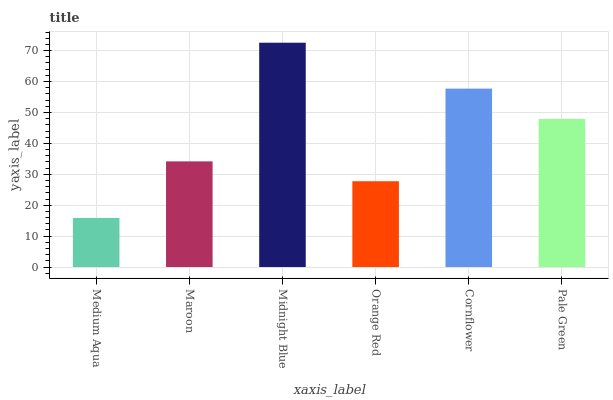Is Medium Aqua the minimum?
Answer yes or no. Yes. Is Midnight Blue the maximum?
Answer yes or no. Yes. Is Maroon the minimum?
Answer yes or no. No. Is Maroon the maximum?
Answer yes or no. No. Is Maroon greater than Medium Aqua?
Answer yes or no. Yes. Is Medium Aqua less than Maroon?
Answer yes or no. Yes. Is Medium Aqua greater than Maroon?
Answer yes or no. No. Is Maroon less than Medium Aqua?
Answer yes or no. No. Is Pale Green the high median?
Answer yes or no. Yes. Is Maroon the low median?
Answer yes or no. Yes. Is Medium Aqua the high median?
Answer yes or no. No. Is Pale Green the low median?
Answer yes or no. No. 